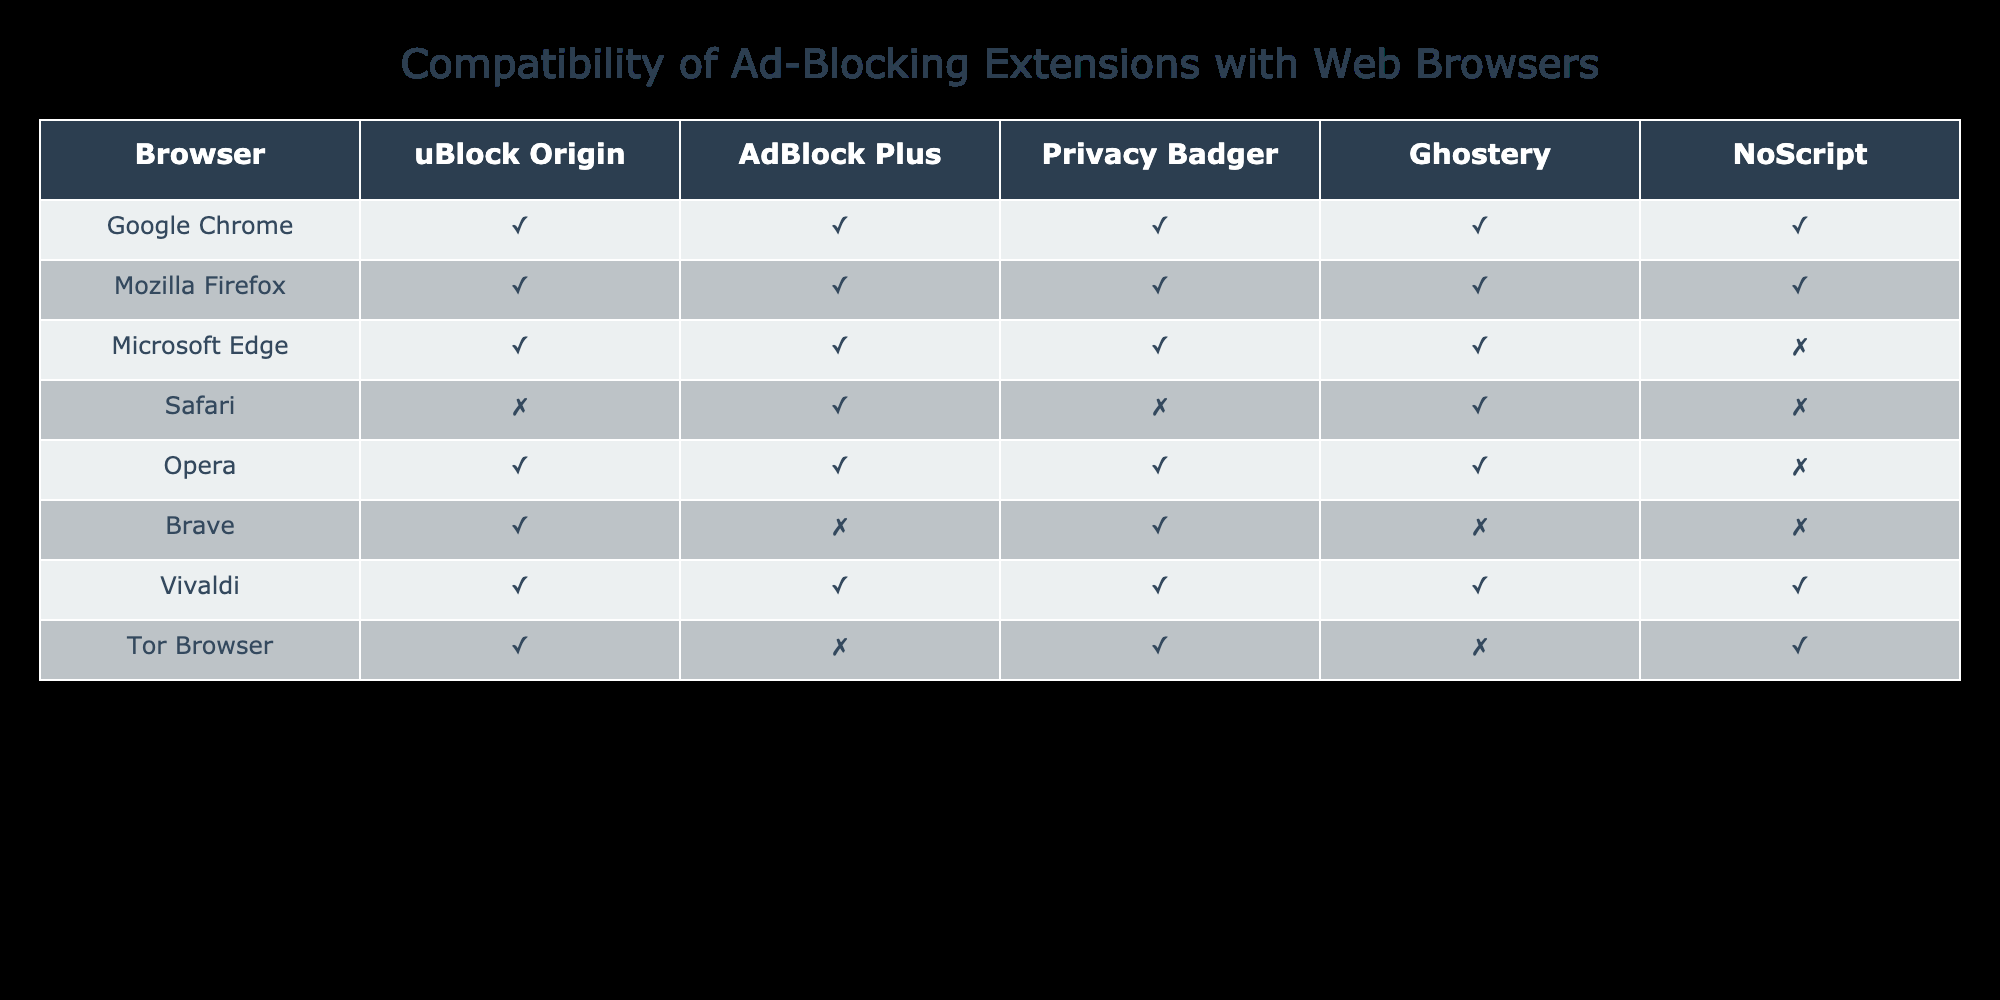What is the compatibility of uBlock Origin with Safari? In the table, the compatibility of uBlock Origin with Safari is indicated as False, meaning it is not compatible with that browser.
Answer: No Which ad-blocking extension is not compatible with Microsoft Edge? From the table, NoScript shows False for Microsoft Edge, indicating it is not compatible with that browser.
Answer: NoScript How many ad-blocking extensions are compatible with Google Chrome? By examining the Google Chrome row, all listed extensions (uBlock Origin, AdBlock Plus, Privacy Badger, Ghostery, NoScript) are marked True, totaling 5 compatible extensions.
Answer: 5 Which browsers have full compatibility (all extensions)? The browsers that have all extensions compatible (all marked True) are Google Chrome, Mozilla Firefox, and Vivaldi.
Answer: Google Chrome, Mozilla Firefox, Vivaldi Is Ghostery compatible with any browser? Referring to the table, Ghostery is marked as compatible (True) with Google Chrome, Mozilla Firefox, Microsoft Edge, and Safari, meaning it is compatible with several browsers.
Answer: Yes How many extensions are compatible with Brave? The Brave row shows uBlock Origin and Privacy Badger as True while AdBlock Plus, Ghostery, and NoScript are False, resulting in 2 compatible extensions.
Answer: 2 Which ad-blocker has the least compatibility overall? By reviewing the False values across all rows, NoScript is compatible only with Google Chrome, Mozilla Firefox, and Tor Browser; hence, it has the least compatibility overall with only 3 out of 8 browsers.
Answer: NoScript If you combine Ghostery and AdBlock Plus, how many browsers remain compatible? Ghostery is compatible with 5 browsers, and AdBlock Plus is compatible with 6 browsers. To find total unique compatibility, the overlaps must be considered. Google Chrome, Mozilla Firefox, and Microsoft Edge are shared between both, so a total of 8 unique compatibles when combined.
Answer: 8 Are there any ad-blockers that both Safari and Microsoft Edge support? Looking at both rows, AdBlock Plus is compatible with Microsoft Edge but not with Safari; other extensions also share similar incompatibility patterns. There are no ad-blockers that support both browsers.
Answer: No 